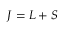Convert formula to latex. <formula><loc_0><loc_0><loc_500><loc_500>{ J } = { L } + { S }</formula> 